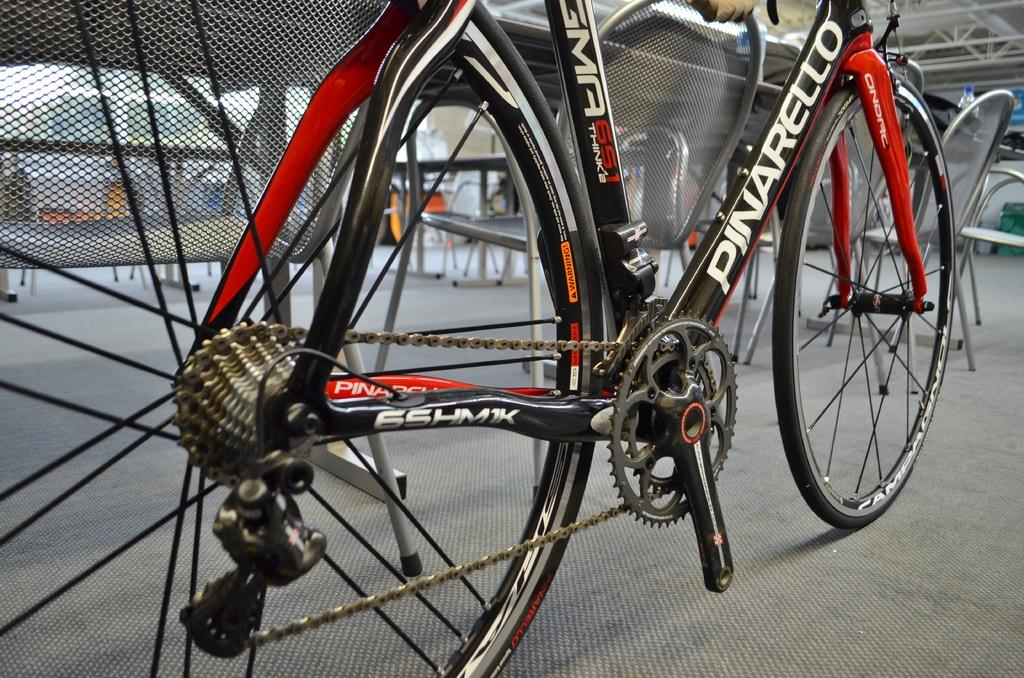What is the main object in the center of the image? There is a cycle in the center of the image. Where is the cycle located? The cycle is on the floor. What type of furniture can be seen in the background of the image? There are chairs and tables in the background of the image. How many snails are crawling on the cycle in the image? There are no snails present in the image; the focus is on the cycle and its location on the floor. 